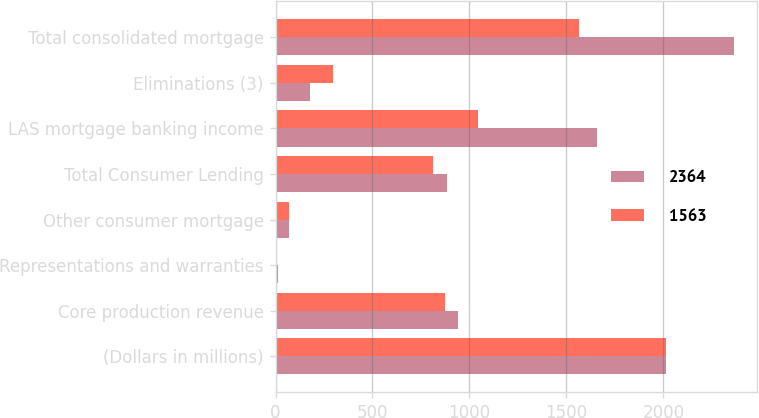<chart> <loc_0><loc_0><loc_500><loc_500><stacked_bar_chart><ecel><fcel>(Dollars in millions)<fcel>Core production revenue<fcel>Representations and warranties<fcel>Other consumer mortgage<fcel>Total Consumer Lending<fcel>LAS mortgage banking income<fcel>Eliminations (3)<fcel>Total consolidated mortgage<nl><fcel>2364<fcel>2015<fcel>942<fcel>11<fcel>70<fcel>883<fcel>1658<fcel>177<fcel>2364<nl><fcel>1563<fcel>2014<fcel>875<fcel>10<fcel>72<fcel>813<fcel>1045<fcel>295<fcel>1563<nl></chart> 